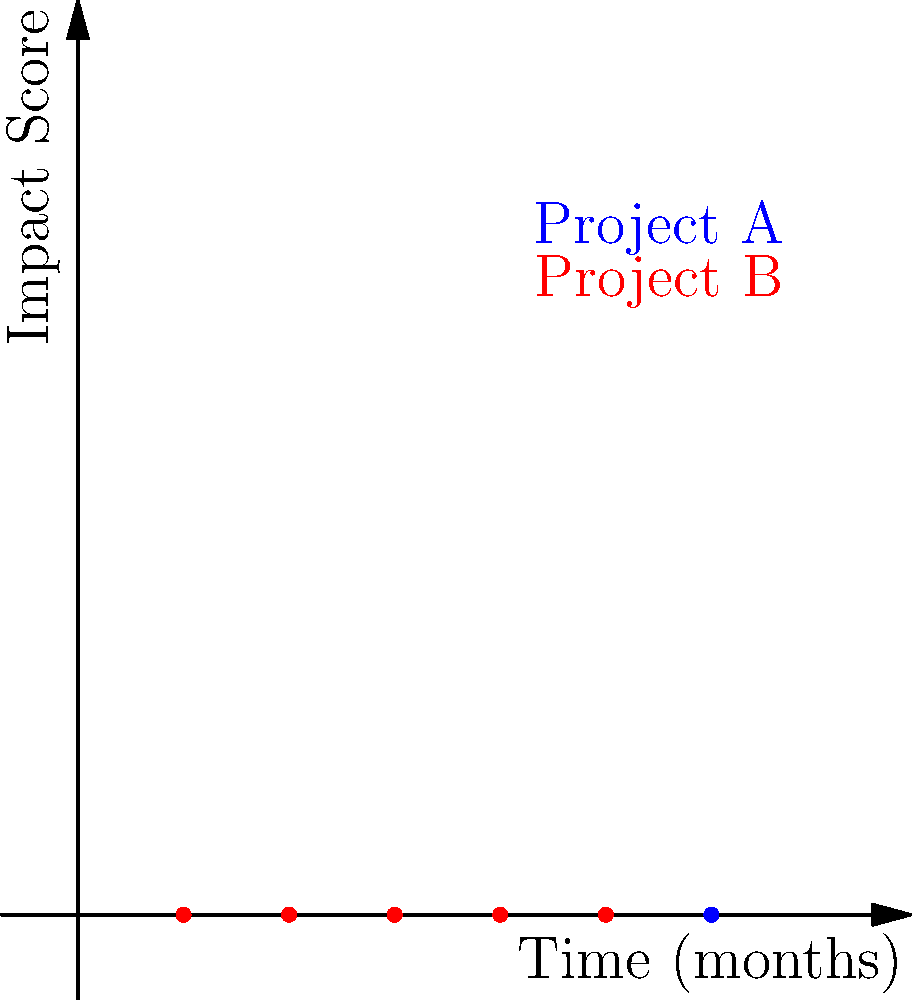The graph shows the impact scores of two projects (A and B) over a 5-month period. Based on the visualization, which project demonstrates a more consistent positive trend in impact scores? Justify your answer using statistical concepts. To determine which project demonstrates a more consistent positive trend, we need to analyze the data points for both projects:

1. Visualize the data:
   - Project A (blue): (1,2), (2,4), (3,3), (4,5), (5,6)
   - Project B (red): (1,1), (2,3), (3,2), (4,4), (5,3)

2. Calculate the slope between consecutive points for each project:
   Project A slopes: 2, -1, 2, 1
   Project B slopes: 2, -1, 2, -1

3. Analyze trend consistency:
   - Project A has 3 positive slopes and 1 negative slope
   - Project B has 2 positive slopes and 2 negative slopes

4. Calculate the overall trend using linear regression:
   - For Project A: $y = 0.9x + 1.5$ (positive slope)
   - For Project B: $y = 0.5x + 1.3$ (positive but smaller slope)

5. Compare variability:
   - Calculate variance of slopes:
     Project A: $Var(A) = 1.58$
     Project B: $Var(B) = 2.25$
   - Project A has lower variance, indicating more consistent change

6. Conclusion:
   Project A demonstrates a more consistent positive trend because:
   a) It has more positive slopes between consecutive points
   b) Its overall trend (linear regression) has a steeper positive slope
   c) It has lower variance in its slopes, indicating more consistent change
Answer: Project A, due to more positive slopes, steeper overall trend, and lower variance in slope changes. 